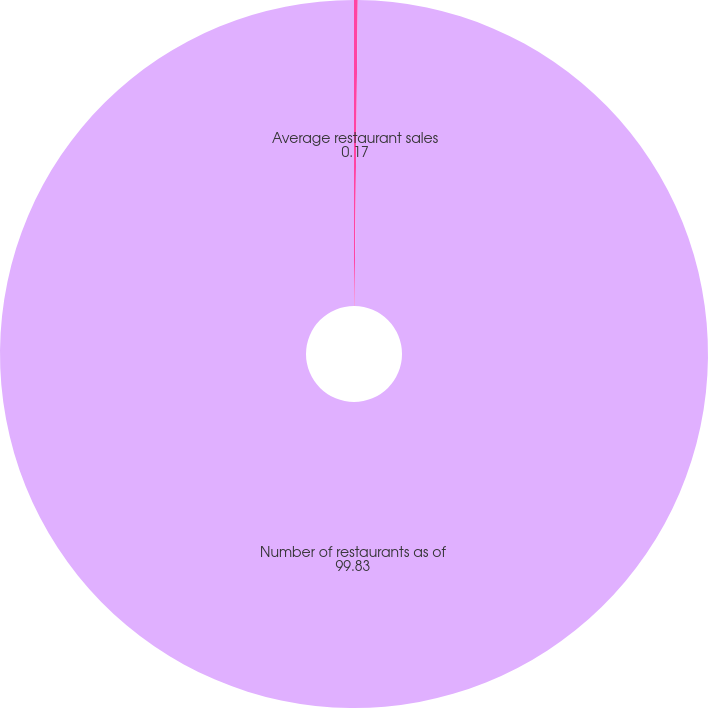Convert chart. <chart><loc_0><loc_0><loc_500><loc_500><pie_chart><fcel>Average restaurant sales<fcel>Number of restaurants as of<nl><fcel>0.17%<fcel>99.83%<nl></chart> 